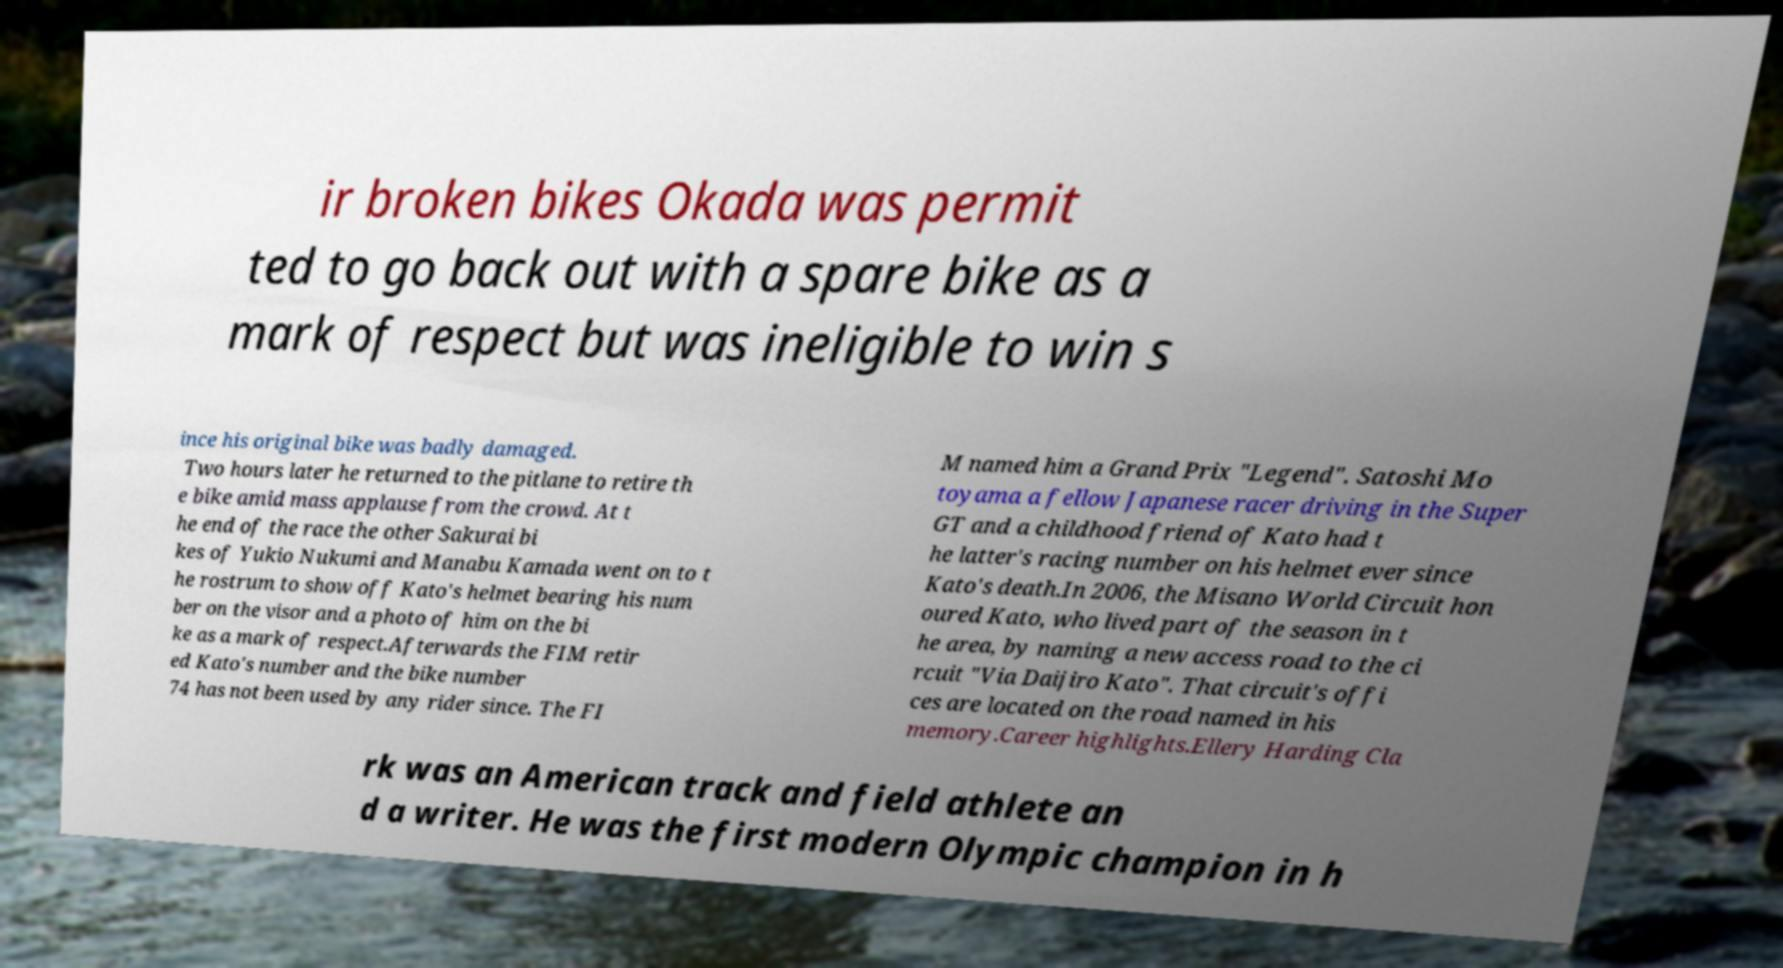Could you extract and type out the text from this image? ir broken bikes Okada was permit ted to go back out with a spare bike as a mark of respect but was ineligible to win s ince his original bike was badly damaged. Two hours later he returned to the pitlane to retire th e bike amid mass applause from the crowd. At t he end of the race the other Sakurai bi kes of Yukio Nukumi and Manabu Kamada went on to t he rostrum to show off Kato's helmet bearing his num ber on the visor and a photo of him on the bi ke as a mark of respect.Afterwards the FIM retir ed Kato's number and the bike number 74 has not been used by any rider since. The FI M named him a Grand Prix "Legend". Satoshi Mo toyama a fellow Japanese racer driving in the Super GT and a childhood friend of Kato had t he latter's racing number on his helmet ever since Kato's death.In 2006, the Misano World Circuit hon oured Kato, who lived part of the season in t he area, by naming a new access road to the ci rcuit "Via Daijiro Kato". That circuit's offi ces are located on the road named in his memory.Career highlights.Ellery Harding Cla rk was an American track and field athlete an d a writer. He was the first modern Olympic champion in h 